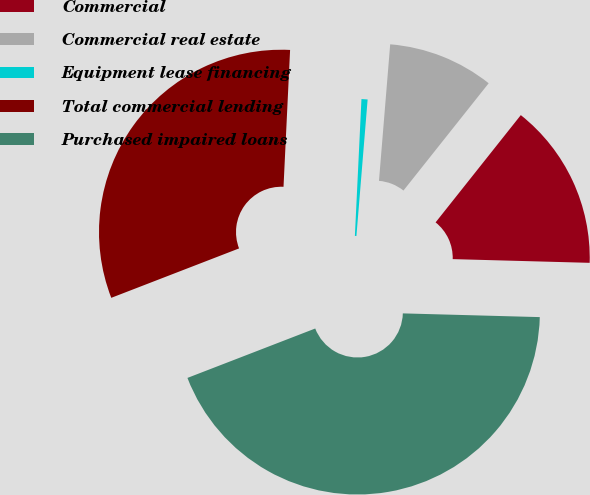<chart> <loc_0><loc_0><loc_500><loc_500><pie_chart><fcel>Commercial<fcel>Commercial real estate<fcel>Equipment lease financing<fcel>Total commercial lending<fcel>Purchased impaired loans<nl><fcel>14.75%<fcel>9.38%<fcel>0.54%<fcel>31.64%<fcel>43.7%<nl></chart> 